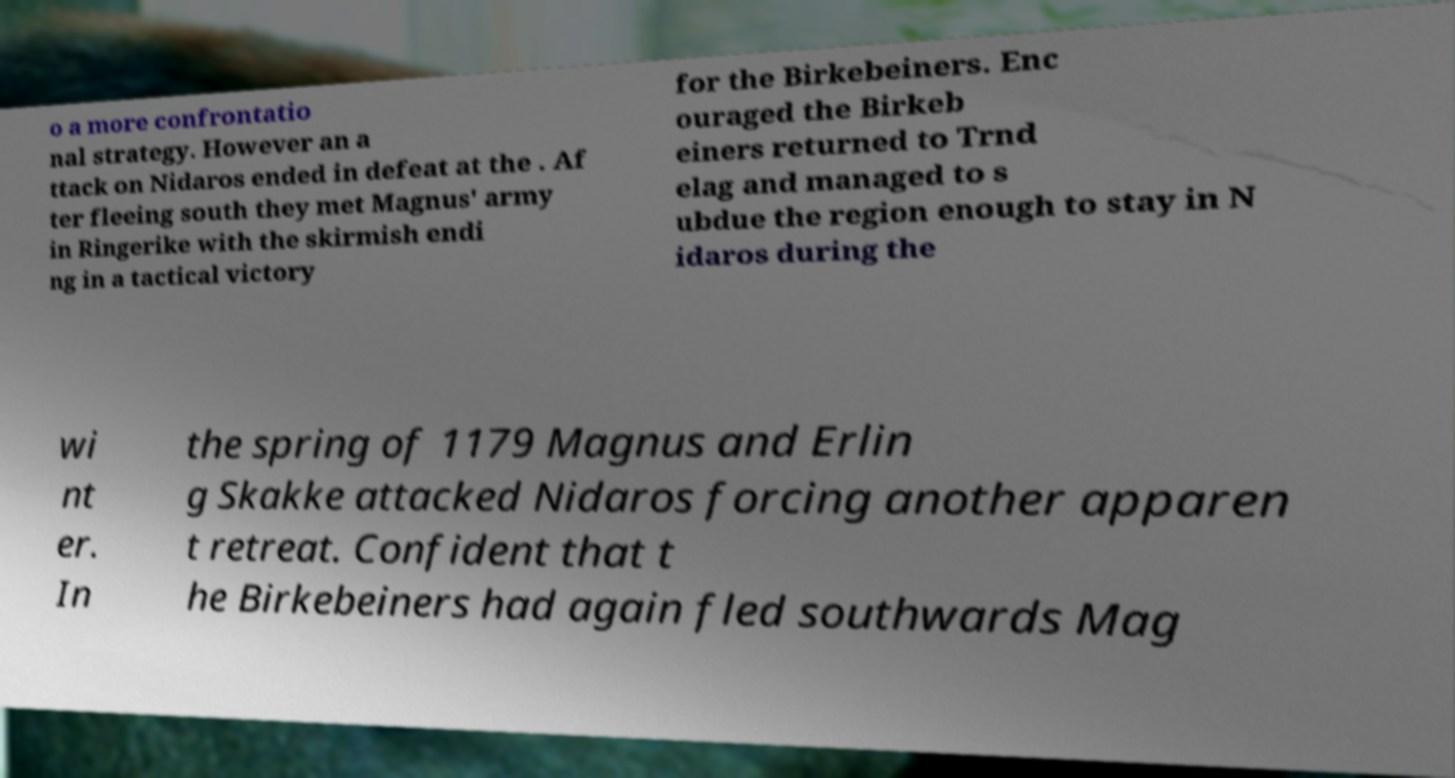Please identify and transcribe the text found in this image. o a more confrontatio nal strategy. However an a ttack on Nidaros ended in defeat at the . Af ter fleeing south they met Magnus' army in Ringerike with the skirmish endi ng in a tactical victory for the Birkebeiners. Enc ouraged the Birkeb einers returned to Trnd elag and managed to s ubdue the region enough to stay in N idaros during the wi nt er. In the spring of 1179 Magnus and Erlin g Skakke attacked Nidaros forcing another apparen t retreat. Confident that t he Birkebeiners had again fled southwards Mag 